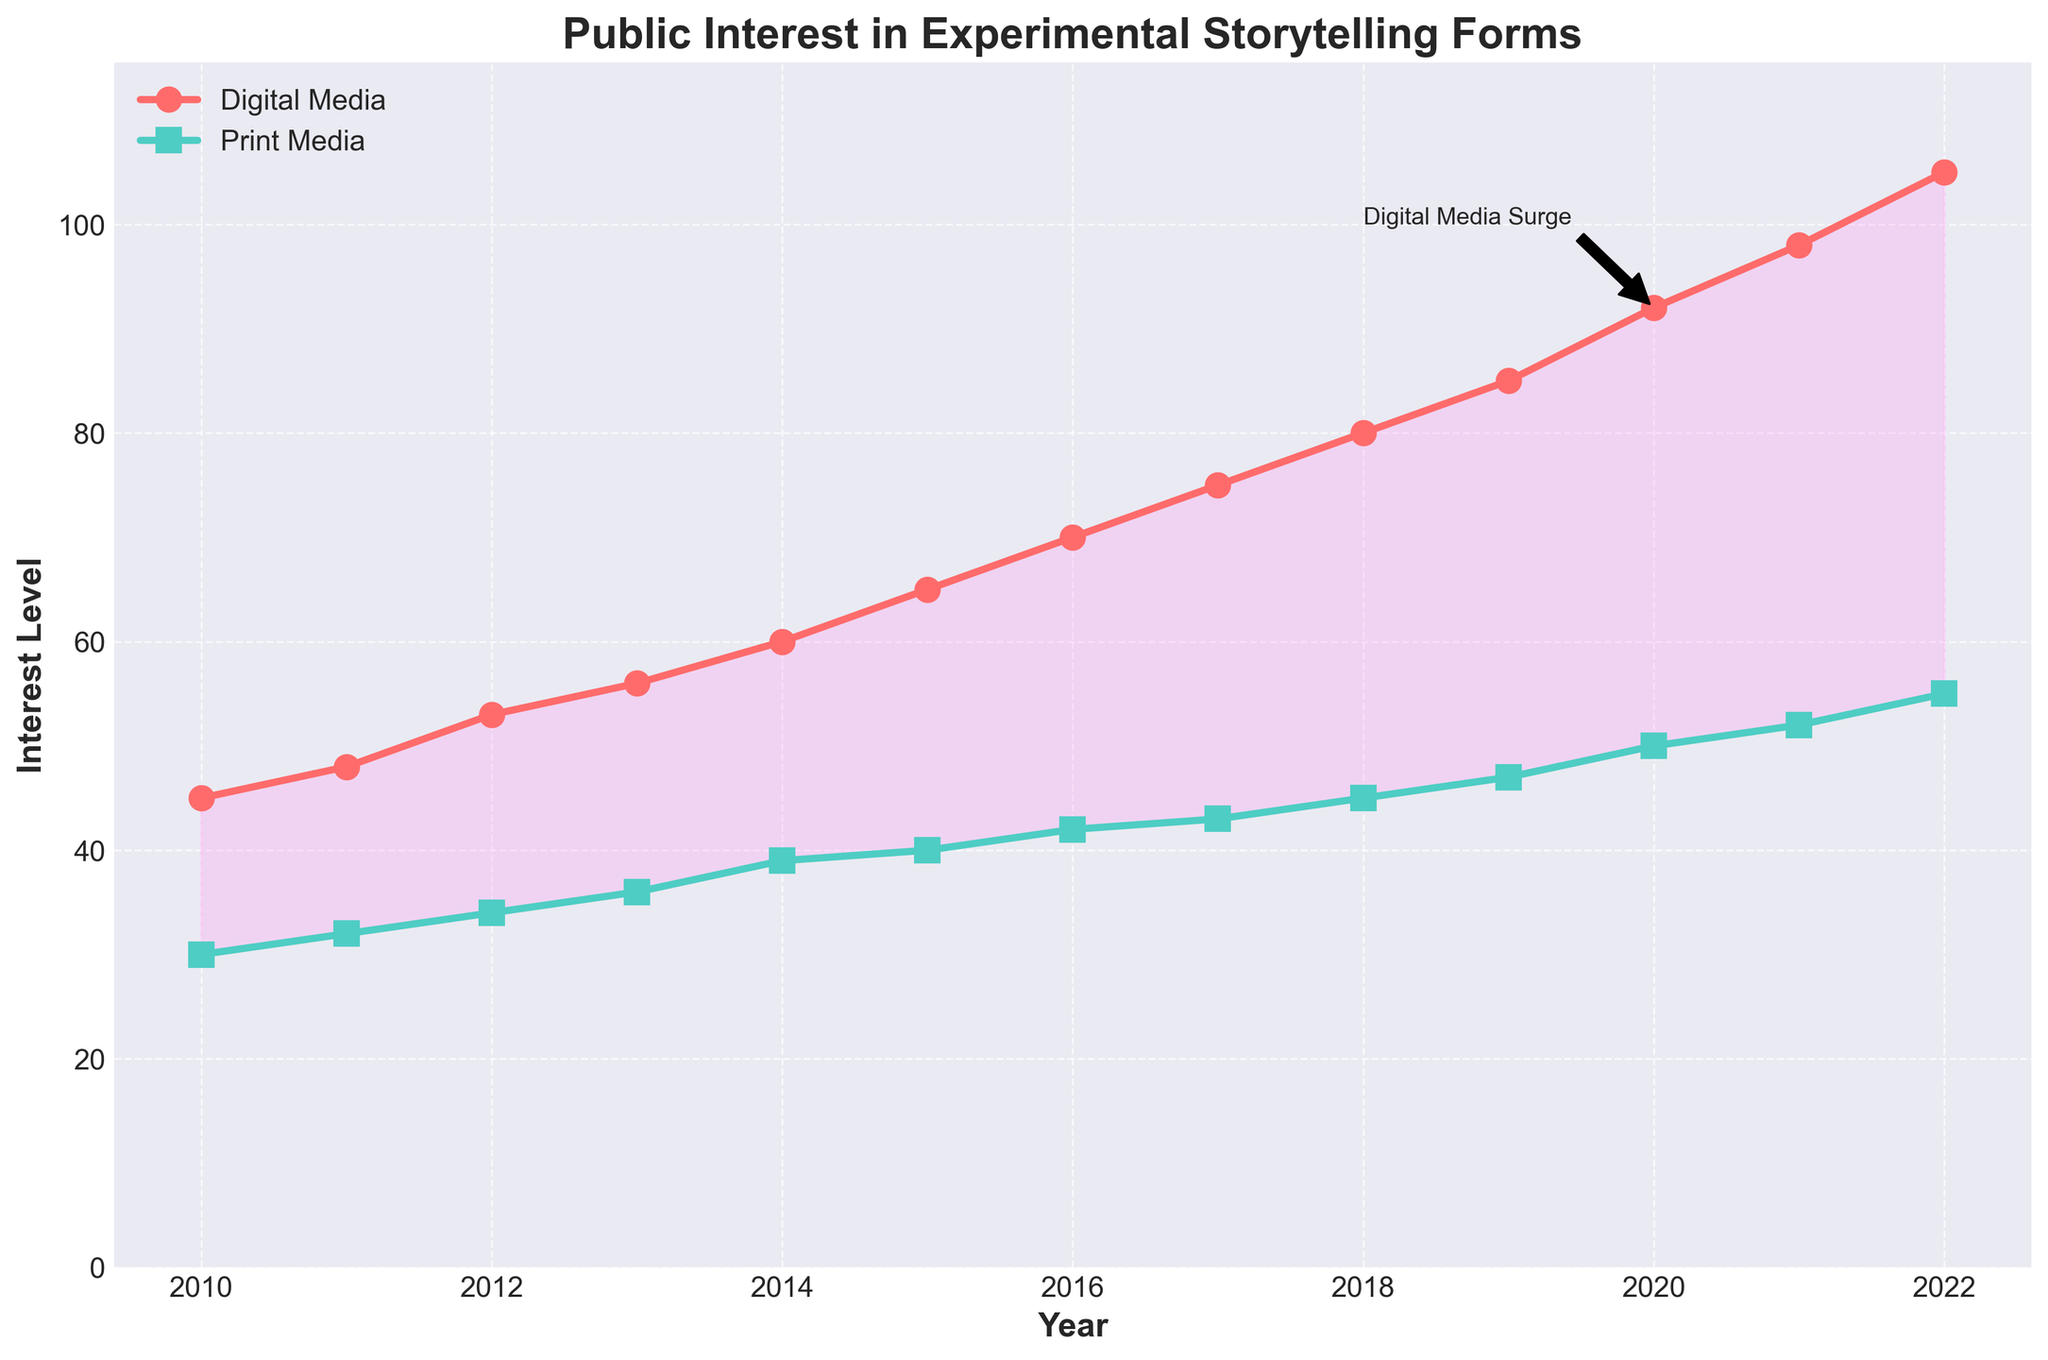What is the title of the plot? The title is typically a textual element that is prominently displayed at the top of the plot, designed to give an overview or summary of the content presented.
Answer: Public Interest in Experimental Storytelling Forms How many years are represented in this plot? By counting the number of distinct year labels along the x-axis of the plot, one can determine the total length of time covered by the plot.
Answer: 13 What is the interest level in digital media in the year 2020? By locating the specific year 2020 on the x-axis and following the corresponding point along the digital media line (colored #FF6B6B), the interest level can be identified.
Answer: 92 How much more interest is there in digital media than print media in 2022? Identify the points for digital media and print media for the year 2022, then calculate the difference between these two values (105 - 55).
Answer: 50 What is the trend in digital media interest from 2010 to 2022? Observe the trajectory of the digital media line (colored #FF6B6B) over the years from 2010 to 2022, noting whether it rises, falls, or remains constant.
Answer: Increasing Which year shows the highest increase in digital media interest compared to the previous year? Calculate the year-over-year difference for digital media interest from 2010 to 2022, and determine the maximum increase among these differences.
Answer: 2022 How does the interest in print media change from 2015 to 2018? Locate the data points corresponding to the years 2015 and 2018 along the print media line (colored #4ECDC4), then observe the direction of change.
Answer: Increases In which year do digital and print media show the smallest difference in interest? Calculate the absolute differences in interest between digital and print media for each year from 2010 to 2022, and identify the year with the smallest difference.
Answer: 2010 Describe the annotation marked 'Digital Media Surge' on the plot. Look for textual callouts pinned to a specific data point on the digital media line, accompanied by an arrow highlighting a notable change or event.
Answer: It marks a significant rise in digital media interest around 2020 What can you infer about the general public's shift in media consumption toward experimental storytelling from this plot? By analyzing the overall trends and comparing the trajectories of digital and print media interests, one can deduce the broader movement or transition in media consumption preferences.
Answer: Shift towards digital media 